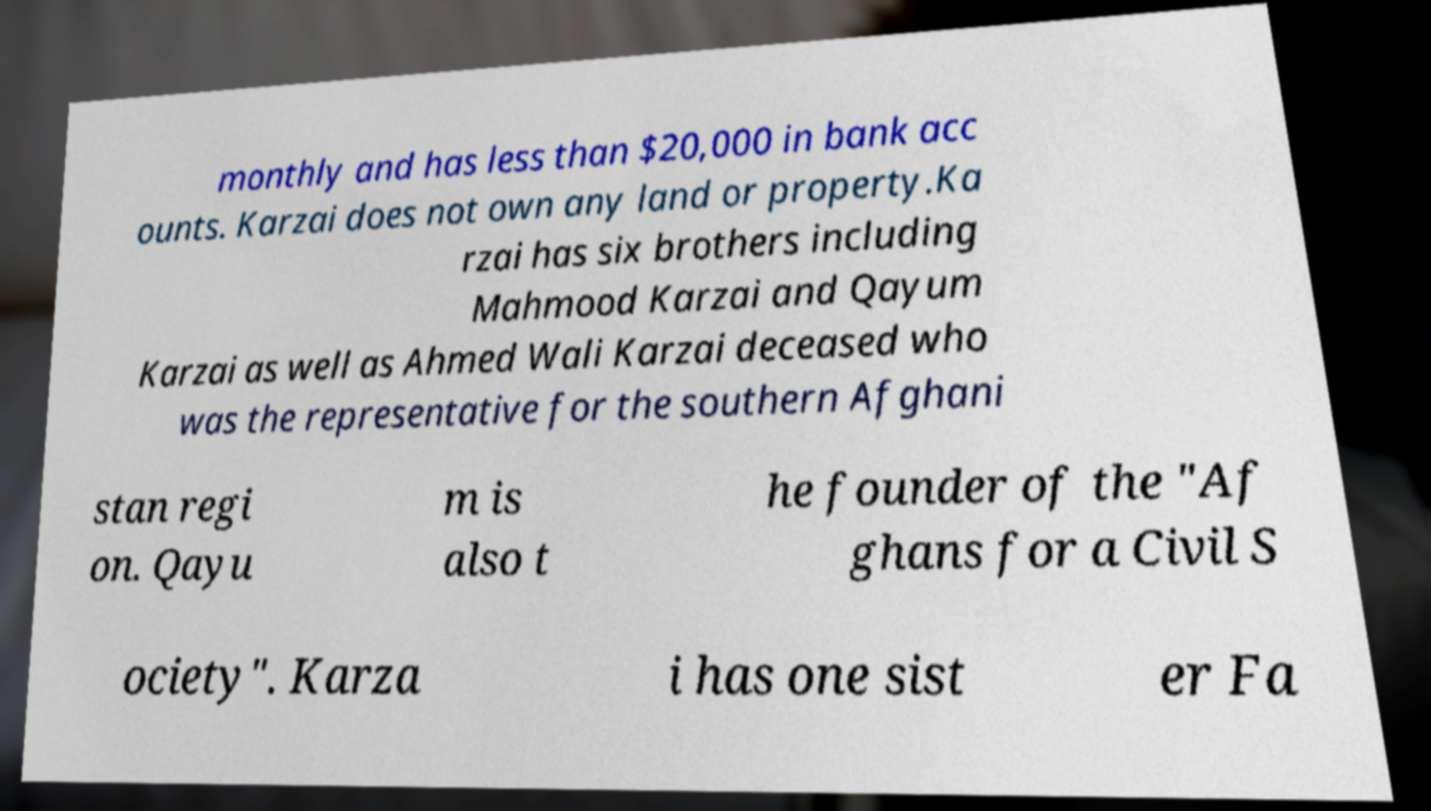Please read and relay the text visible in this image. What does it say? monthly and has less than $20,000 in bank acc ounts. Karzai does not own any land or property.Ka rzai has six brothers including Mahmood Karzai and Qayum Karzai as well as Ahmed Wali Karzai deceased who was the representative for the southern Afghani stan regi on. Qayu m is also t he founder of the "Af ghans for a Civil S ociety". Karza i has one sist er Fa 